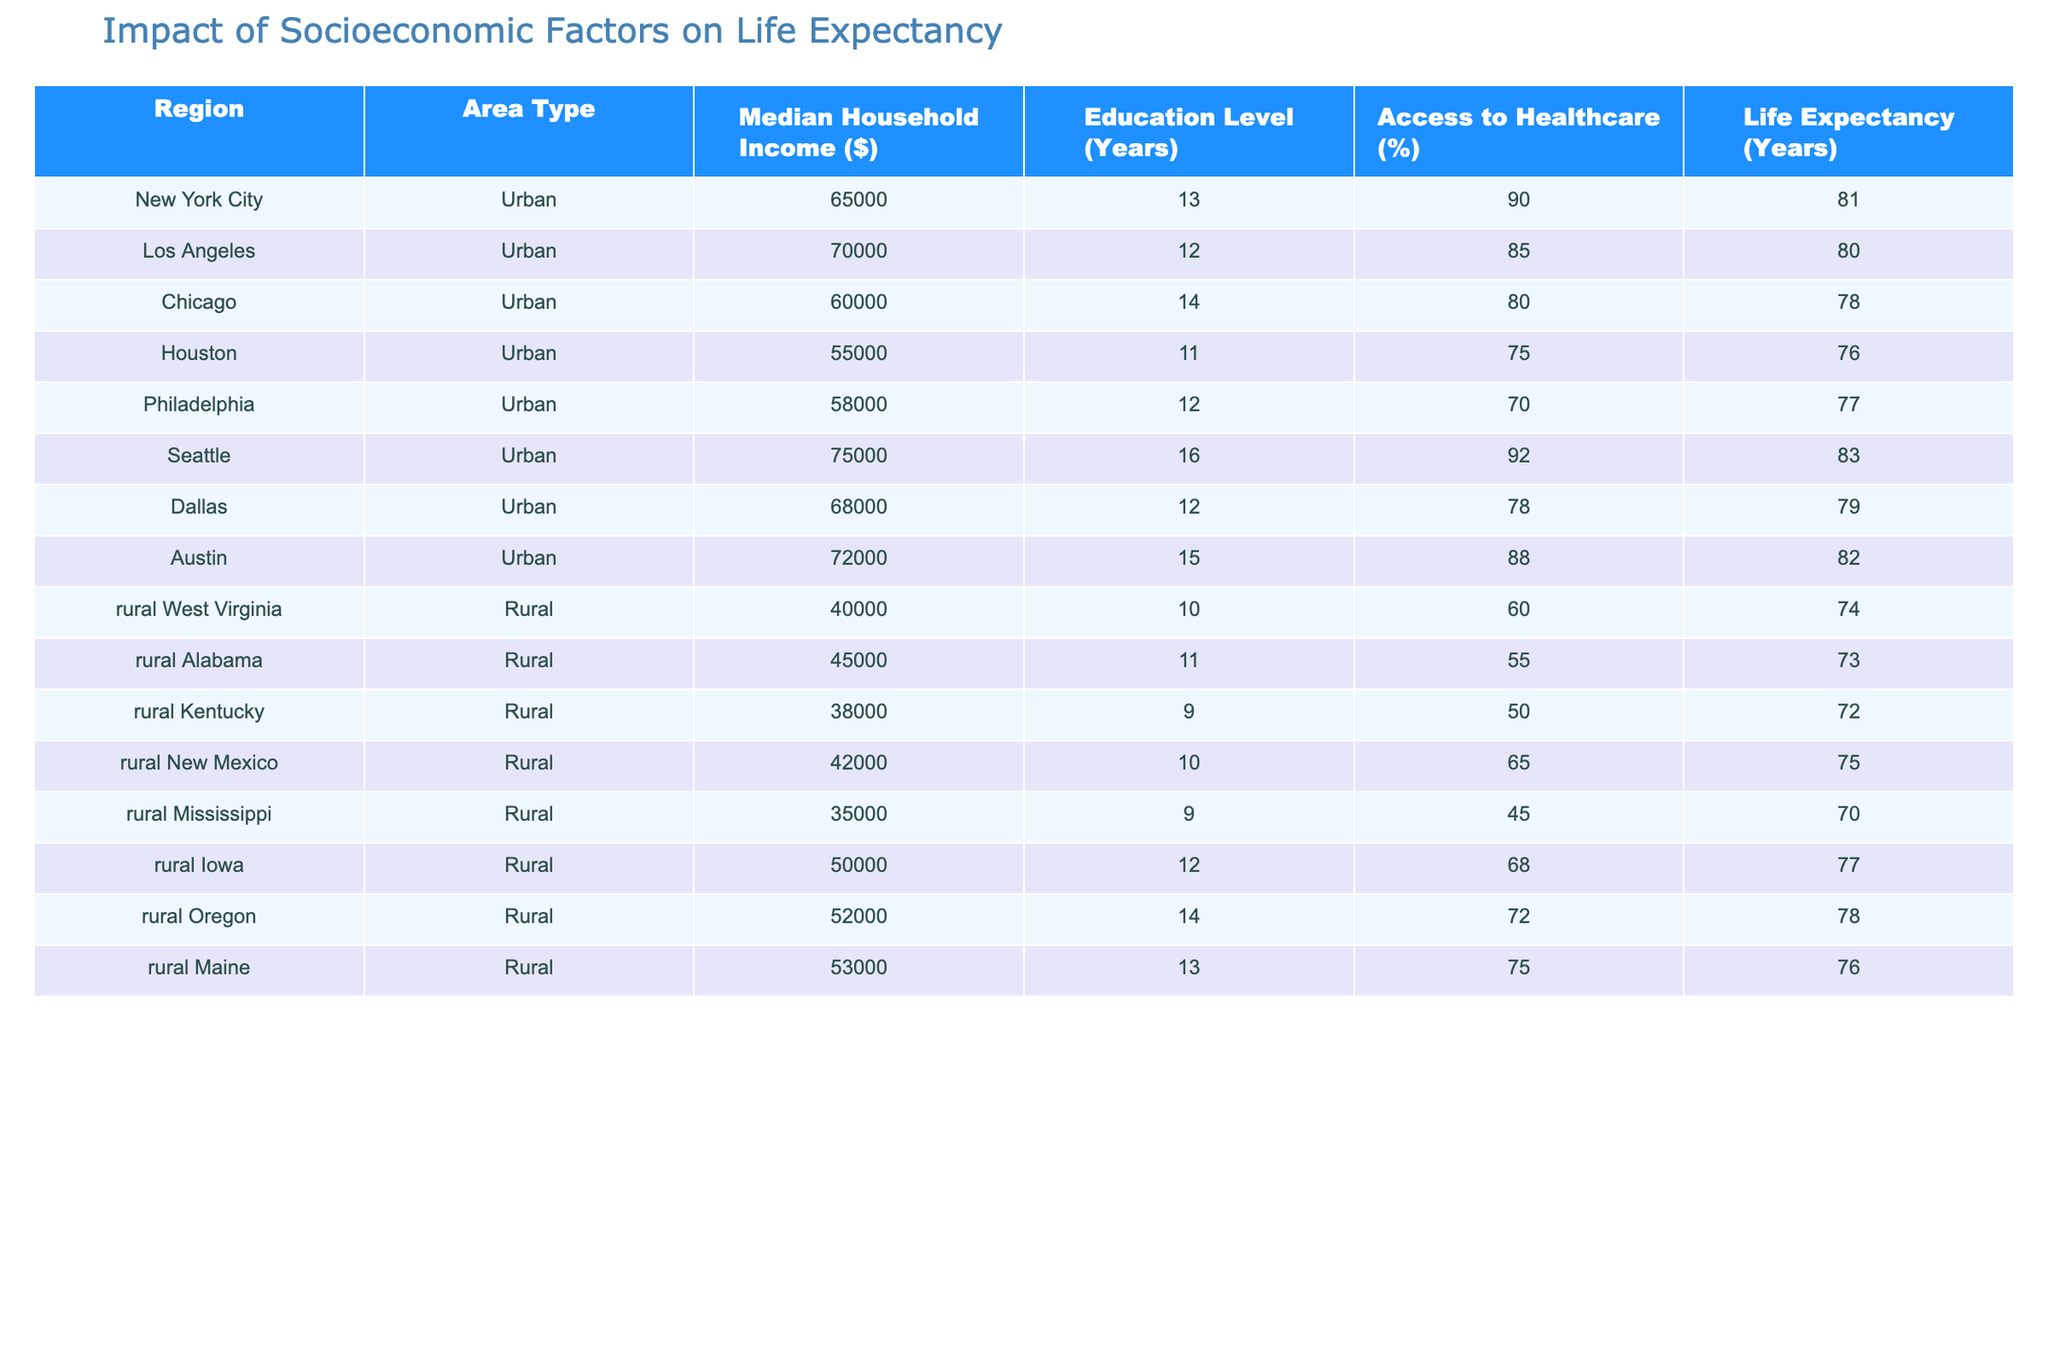What is the life expectancy in New York City? From the table, we see that the life expectancy listed for New York City is 81 years.
Answer: 81 years What is the median household income for rural Alabama? By looking at the row for rural Alabama, we find that the median household income is $45,000.
Answer: $45,000 Which area type has the highest average life expectancy? The average life expectancy for urban areas is (81 + 80 + 78 + 76 + 77 + 83 + 79 + 82) / 8 = 79.875 years, while for rural areas it is (74 + 73 + 72 + 75 + 70 + 77 + 78 + 76) / 8 = 74.625 years. Thus, urban areas have the highest average life expectancy.
Answer: Urban areas Is it true that the access to healthcare is higher in Seattle than in Chicago? Checking the access to healthcare percentages, Seattle shows 92% whereas Chicago shows 80%. Since 92% is greater than 80%, the statement is true.
Answer: Yes What is the difference in median household income between rural Kentucky and urban Houston? The median household income for rural Kentucky is $38,000 and for urban Houston, it is $55,000. The difference is $55,000 - $38,000 = $17,000.
Answer: $17,000 What is the average education level (in years) for the urban area type? To find the average education level for urban areas, we sum the education levels: (13 + 12 + 14 + 11 + 12 + 16 + 12 + 15) = 111 years. There are 8 data points, so the average is 111 / 8 = 13.875 years.
Answer: 13.875 years In which region is the lowest access to healthcare found? By comparing the access to healthcare percentages, rural Mississippi has the lowest at 45%.
Answer: Rural Mississippi What is the median life expectancy for rural areas? The life expectancies for rural areas are: 74, 73, 72, 75, 70, 77, 78, and 76. To find the median, we order these values: 70, 72, 73, 74, 75, 76, 77, 78. Since there are 8 values, the median will be the average of the 4th and 5th value: (74 + 75) / 2 = 74.5 years.
Answer: 74.5 years 